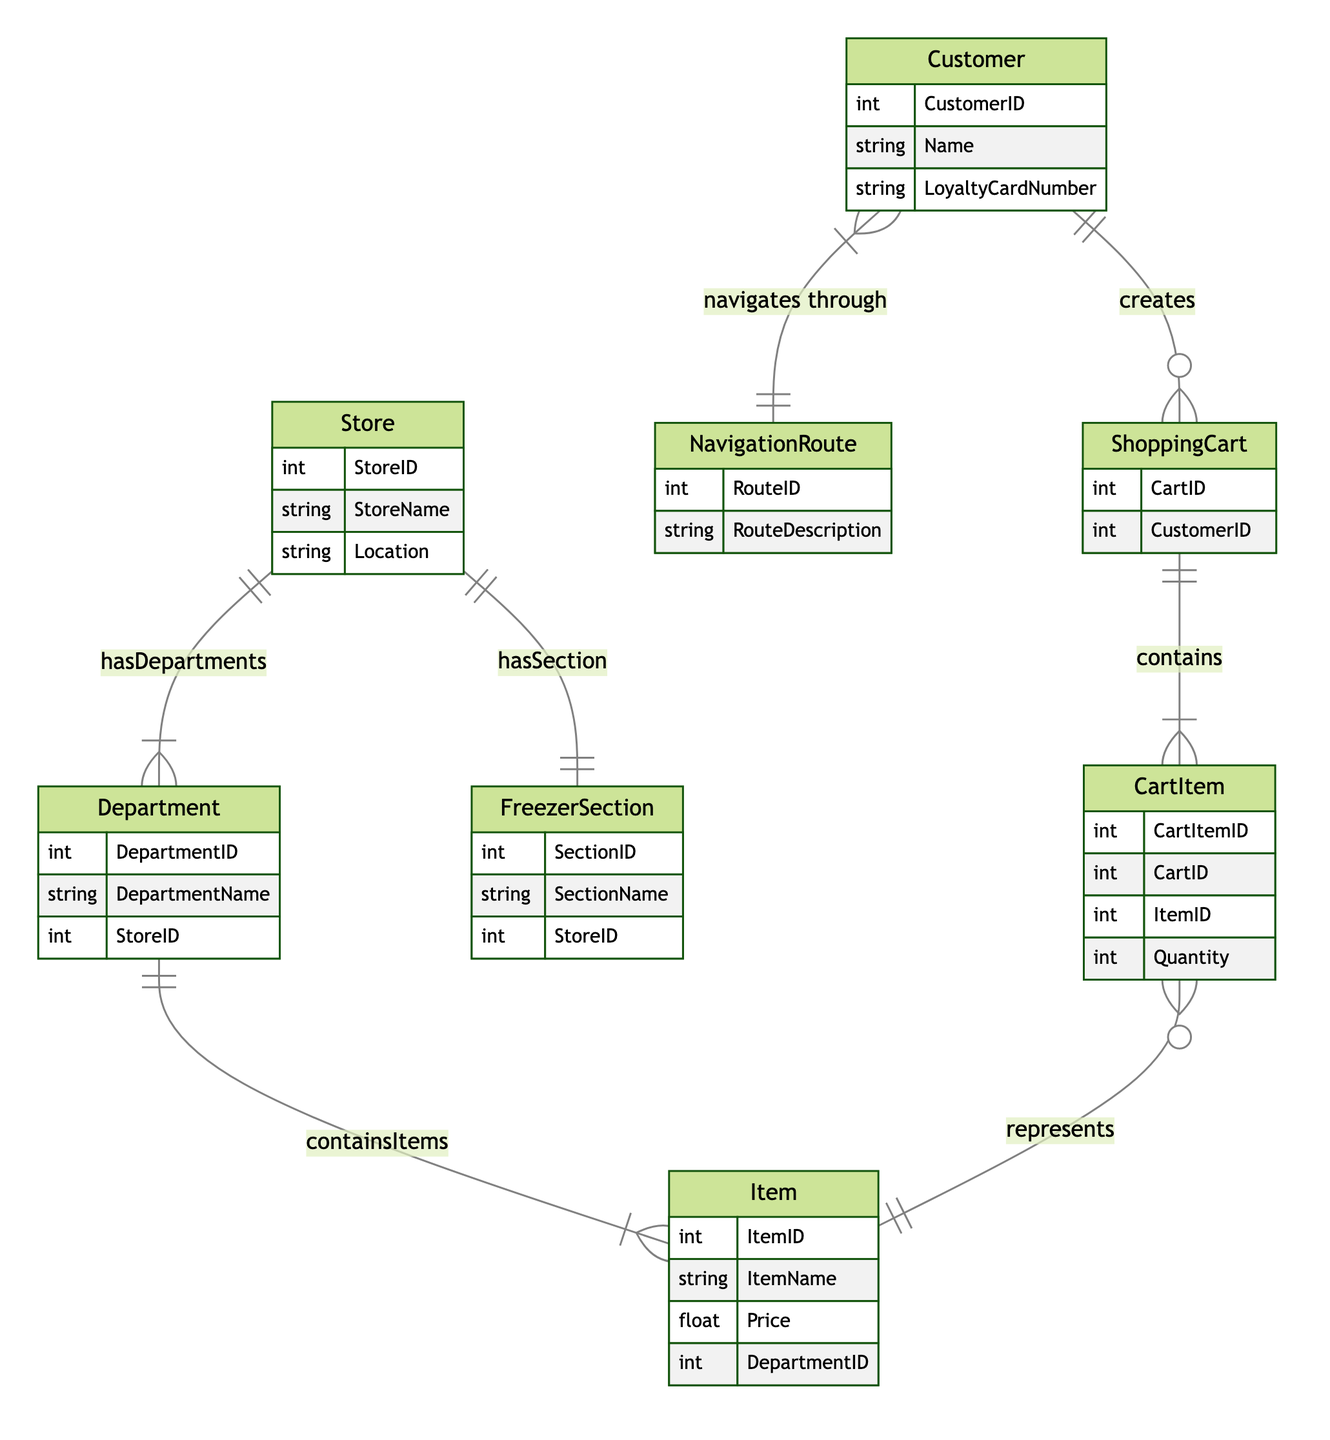What is the primary key of the Customer entity? The primary key of the Customer entity is "CustomerID," which uniquely identifies each customer in the dataset. This is indicated by the attribute listed under the Customer entity in the diagram.
Answer: CustomerID How many relationships does the Store entity have? The Store entity has three relationships: "hasDepartments," "hasSection," and is indirectly part of the "containsItems" relationship through the Department. Therefore, counting the direct relationships, it has two.
Answer: 2 What relationship exists between Item and CartItem? The relationship between Item and CartItem is "represents." This indicates that a CartItem represents a specific Item in the ShoppingCart. This is shown by the connecting line labeled "represents" between the two entities.
Answer: represents Which entity has a 1-to-many relationship with ShoppingCart? The Customer entity has a 1-to-many relationship with ShoppingCart, indicated by the "creates" relationship. This means that one customer can create multiple shopping carts.
Answer: Customer How many items can be contained in a ShoppingCart? A ShoppingCart can contain multiple CartItems. Hence, there can be more than one item in a shopping cart, determined by the "contains" relationship between ShoppingCart and CartItem, which is 1-to-many.
Answer: Many Which department contains the items? The Department entity contains the items, indicated by the "containsItems" relationship between Department and Item, showing that each department can contain multiple items.
Answer: Department What is the relationship type between Customer and NavigationRoute? The relationship type between Customer and NavigationRoute is "many-to-many." This means a customer can navigate through multiple routes, and multiple customers can navigate through the same route. This is specified in the diagram.
Answer: many-to-many How many freezer sections does each store have? Each store has exactly one freezer section, as indicated by the "hasSection" relationship, which shows a 1-to-1 relationship between Store and FreezerSection.
Answer: 1 What attribute describes the price of an Item? The attribute that describes the price of an Item is "Price." This attribute is included in the Item entity and denotes the cost of each item sold in the store.
Answer: Price 